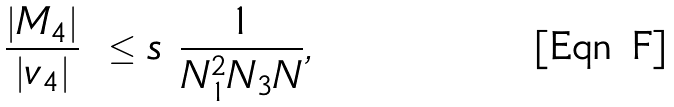Convert formula to latex. <formula><loc_0><loc_0><loc_500><loc_500>\frac { | M _ { 4 } | } { | v _ { 4 } | } \ \leq s \ \frac { 1 } { N _ { 1 } ^ { 2 } N _ { 3 } N } ,</formula> 